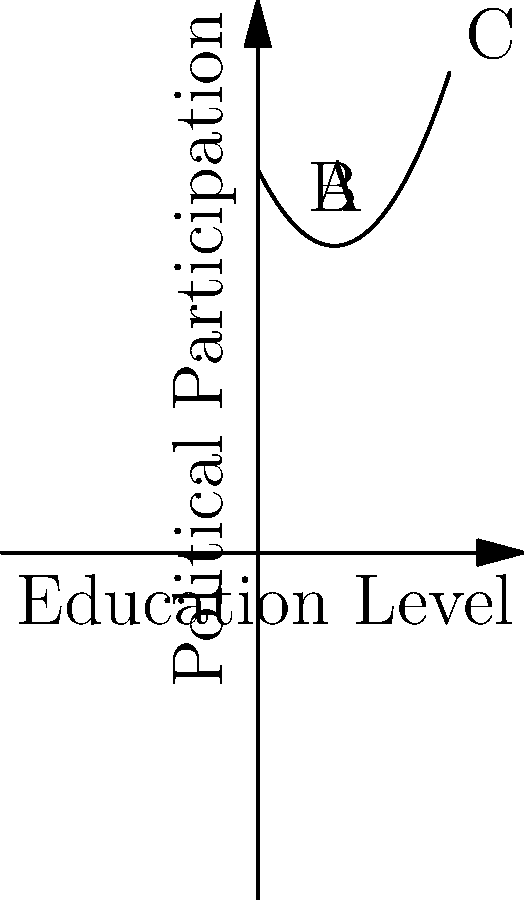The graph shows the relationship between education levels and political participation in a democratic society. Which point on the curve represents the highest level of political participation, and what does this suggest about the correlation between education and political engagement? To answer this question, we need to analyze the polynomial curve and its implications:

1. The x-axis represents education levels, increasing from left to right.
2. The y-axis represents political participation, increasing from bottom to top.
3. The curve is a parabola opening upwards, suggesting a quadratic relationship.

Let's examine the three labeled points:

- Point A: Low education level, moderate political participation
- Point B: Medium education level, lowest political participation
- Point C: Highest education level, highest political participation

The curve shows that:

1. Initially, as education increases from A to B, political participation decreases.
2. After point B, as education continues to increase towards C, political participation rises dramatically.

The highest point on the curve is C, representing the highest level of political participation. This suggests that:

1. There's a non-linear relationship between education and political participation.
2. Very high levels of education are associated with the highest levels of political engagement.
3. There may be a threshold effect, where political participation increases significantly only after a certain level of education is reached.

This pattern could be explained by factors such as:
- Increased understanding of complex political issues with higher education
- Greater access to information and resources
- Development of critical thinking skills
- Exposure to diverse perspectives in higher educational settings
Answer: Point C; suggests a positive non-linear correlation with a threshold effect. 